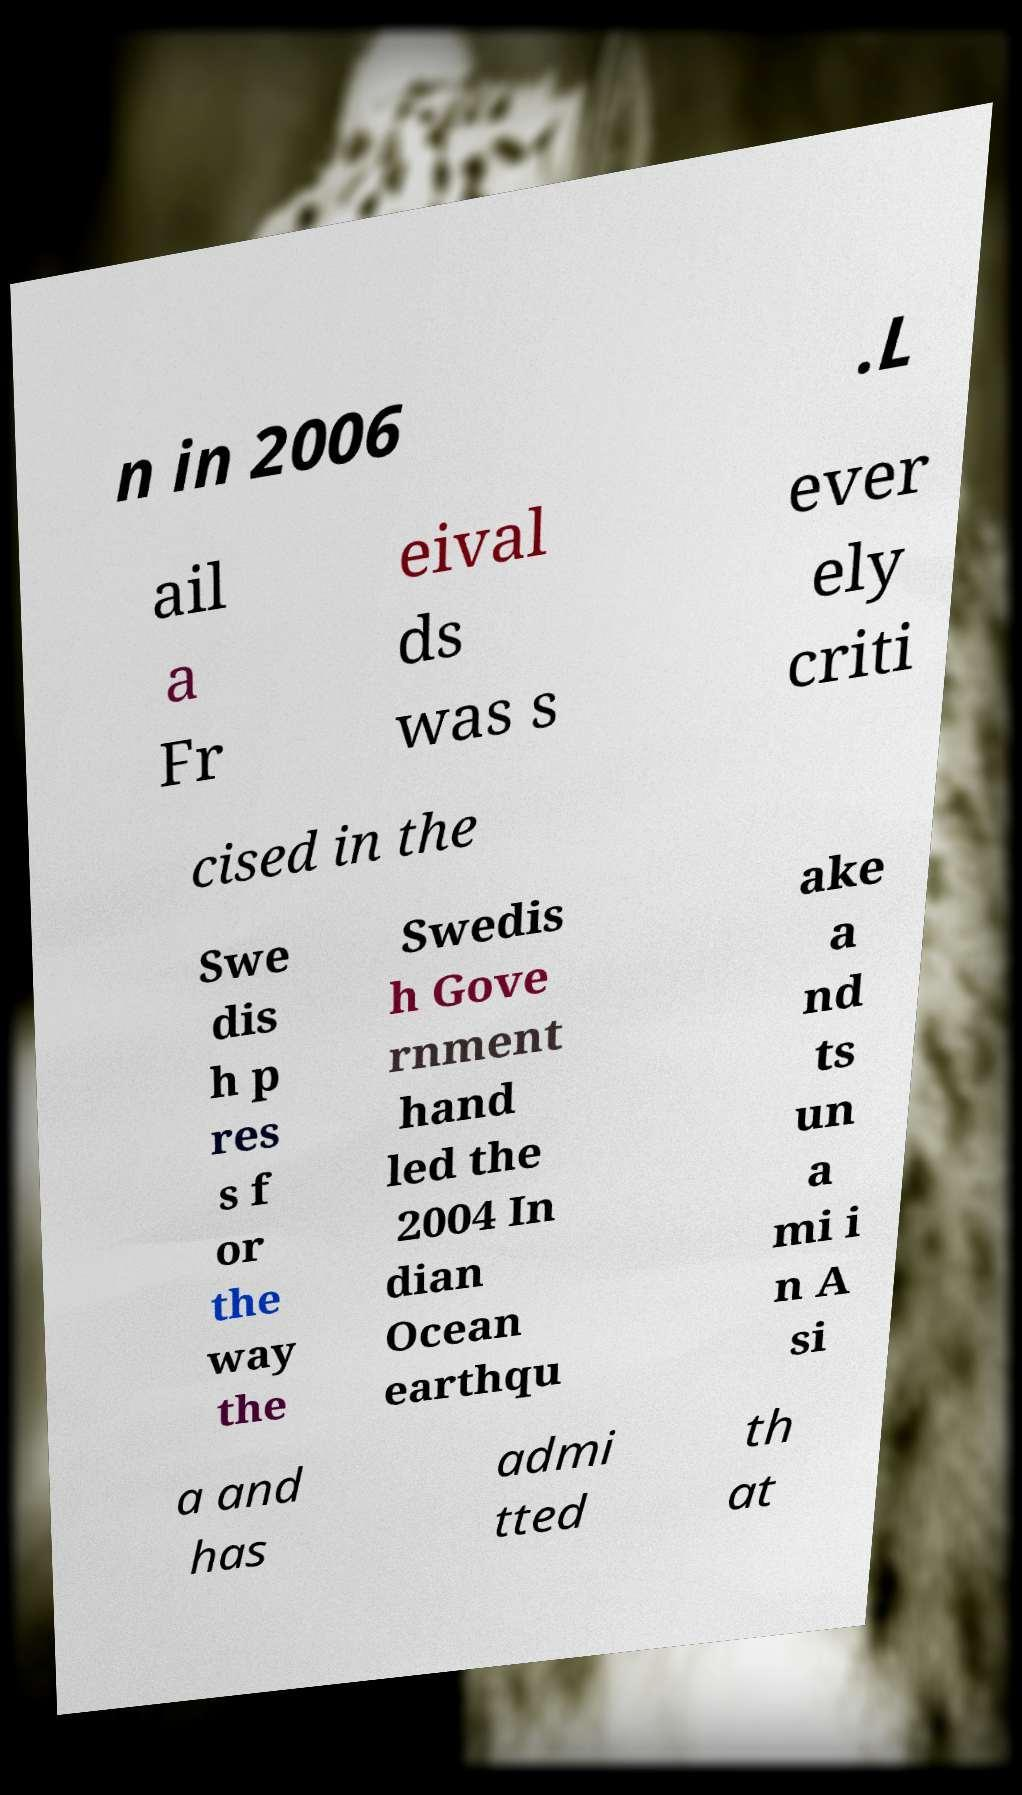Could you extract and type out the text from this image? n in 2006 .L ail a Fr eival ds was s ever ely criti cised in the Swe dis h p res s f or the way the Swedis h Gove rnment hand led the 2004 In dian Ocean earthqu ake a nd ts un a mi i n A si a and has admi tted th at 